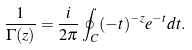Convert formula to latex. <formula><loc_0><loc_0><loc_500><loc_500>\frac { 1 } { \Gamma ( z ) } = \frac { i } { 2 \pi } \oint _ { C } ( - t ) ^ { - z } e ^ { - t } d t .</formula> 